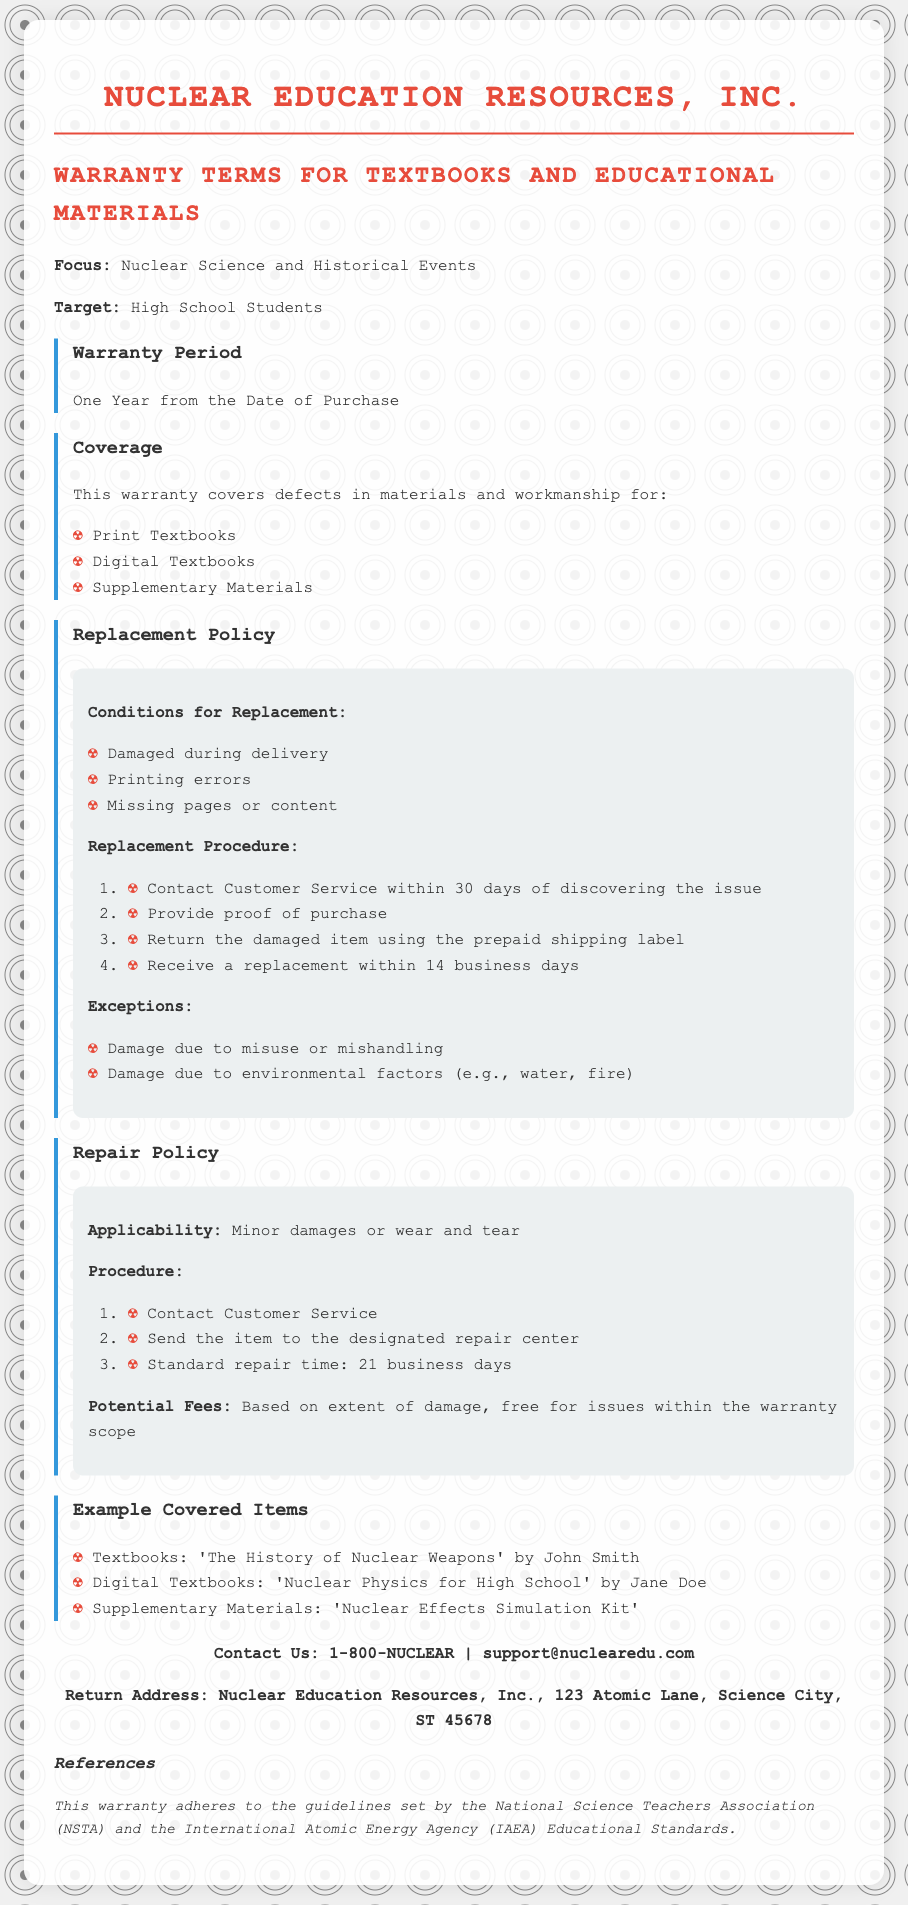What is the warranty period for textbooks? The warranty period is specified in the document as one year from the date of purchase.
Answer: One Year What does the warranty cover? The document lists specific items that the warranty covers, including print textbooks and digital textbooks.
Answer: Defects in materials and workmanship for Print Textbooks, Digital Textbooks, and Supplementary Materials What is required for a replacement? The document outlines conditions that must be met for a replacement, such as being damaged during delivery.
Answer: Damaged during delivery, printing errors, missing pages or content How long do you have to contact customer service for a replacement? The document states a specific timeframe for contacting customer service regarding replacements.
Answer: 30 days What is the standard repair time for items sent for repair? The repair policy includes a standard timeframe for repairs, which is mentioned in the document.
Answer: 21 business days What should you do if you need to send an item for repair? The document outlines the procedure to be followed if an item needs repair, including contacting customer service.
Answer: Contact Customer Service, send the item to the designated repair center What is covered under the repair policy? The document explains the types of damages applicable under the repair policy, specifically focusing on minor damages.
Answer: Minor damages or wear and tear What is the contact number for customer service? The document includes contact information for customer service, which consists of a phone number.
Answer: 1-800-NUCLEAR What types of items are examples of covered materials? The document provides specific examples of textbooks and supplementary materials that fall under warranty coverage.
Answer: 'The History of Nuclear Weapons', 'Nuclear Physics for High School', 'Nuclear Effects Simulation Kit' 